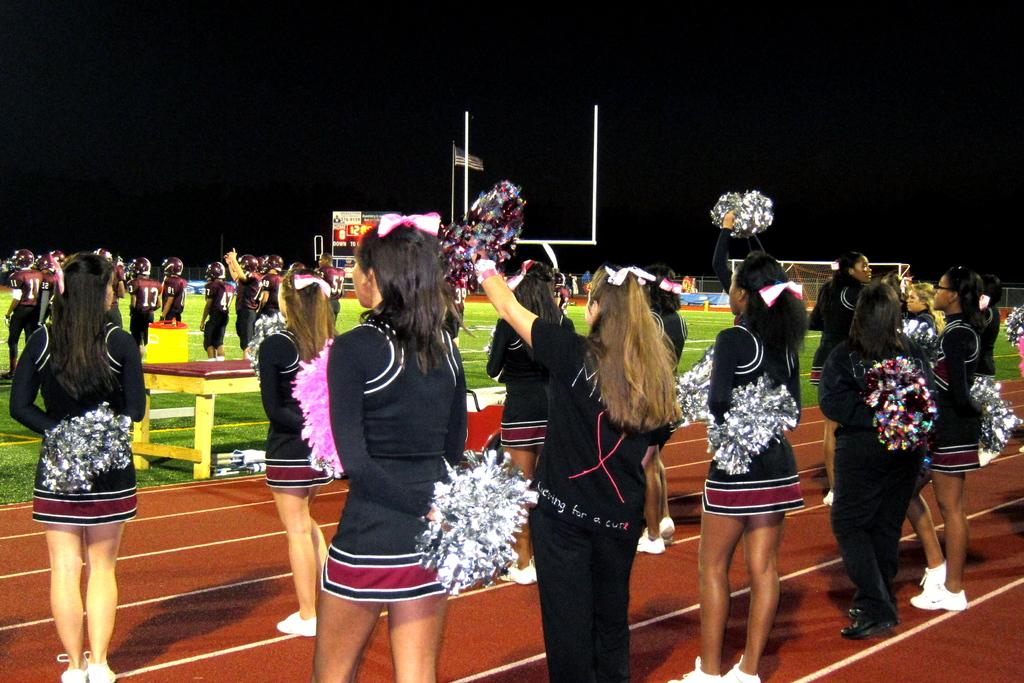What type of people can be seen in the image? There are cheer girls in the image. What are the cheer girls wearing? The cheer girls are wearing black dresses. What position are the cheer girls in? The cheer girls are standing. Who else is present in the image besides the cheer girls? There are players in the image. Where are the players located? The players are standing on a play field. What flavor of friction can be seen between the cheer girls and the players in the image? There is no friction present between the cheer girls and the players in the image, and therefore no flavor can be associated with it. 